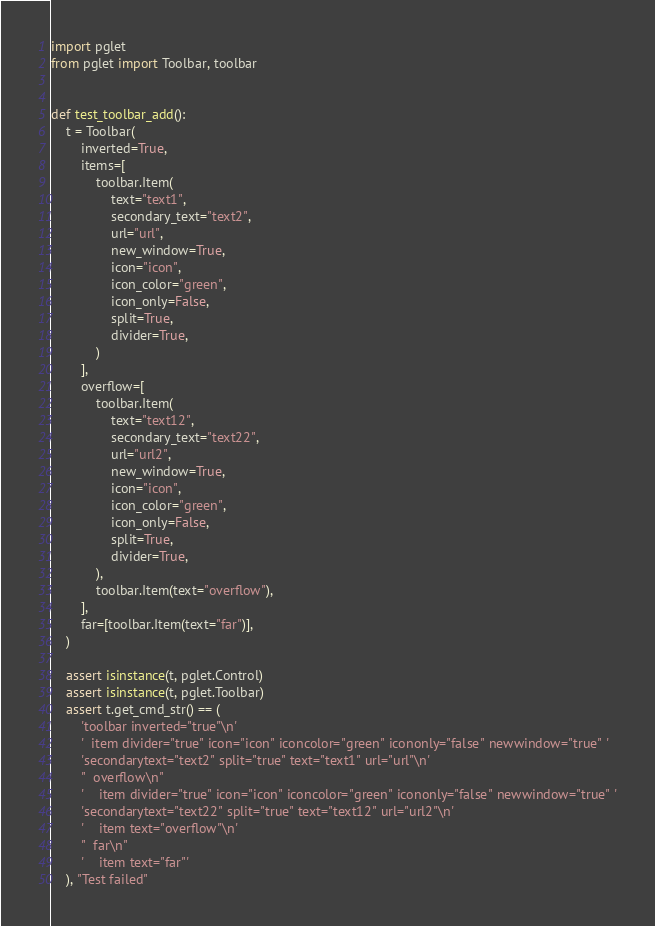<code> <loc_0><loc_0><loc_500><loc_500><_Python_>import pglet
from pglet import Toolbar, toolbar


def test_toolbar_add():
    t = Toolbar(
        inverted=True,
        items=[
            toolbar.Item(
                text="text1",
                secondary_text="text2",
                url="url",
                new_window=True,
                icon="icon",
                icon_color="green",
                icon_only=False,
                split=True,
                divider=True,
            )
        ],
        overflow=[
            toolbar.Item(
                text="text12",
                secondary_text="text22",
                url="url2",
                new_window=True,
                icon="icon",
                icon_color="green",
                icon_only=False,
                split=True,
                divider=True,
            ),
            toolbar.Item(text="overflow"),
        ],
        far=[toolbar.Item(text="far")],
    )

    assert isinstance(t, pglet.Control)
    assert isinstance(t, pglet.Toolbar)
    assert t.get_cmd_str() == (
        'toolbar inverted="true"\n'
        '  item divider="true" icon="icon" iconcolor="green" icononly="false" newwindow="true" '
        'secondarytext="text2" split="true" text="text1" url="url"\n'
        "  overflow\n"
        '    item divider="true" icon="icon" iconcolor="green" icononly="false" newwindow="true" '
        'secondarytext="text22" split="true" text="text12" url="url2"\n'
        '    item text="overflow"\n'
        "  far\n"
        '    item text="far"'
    ), "Test failed"
</code> 